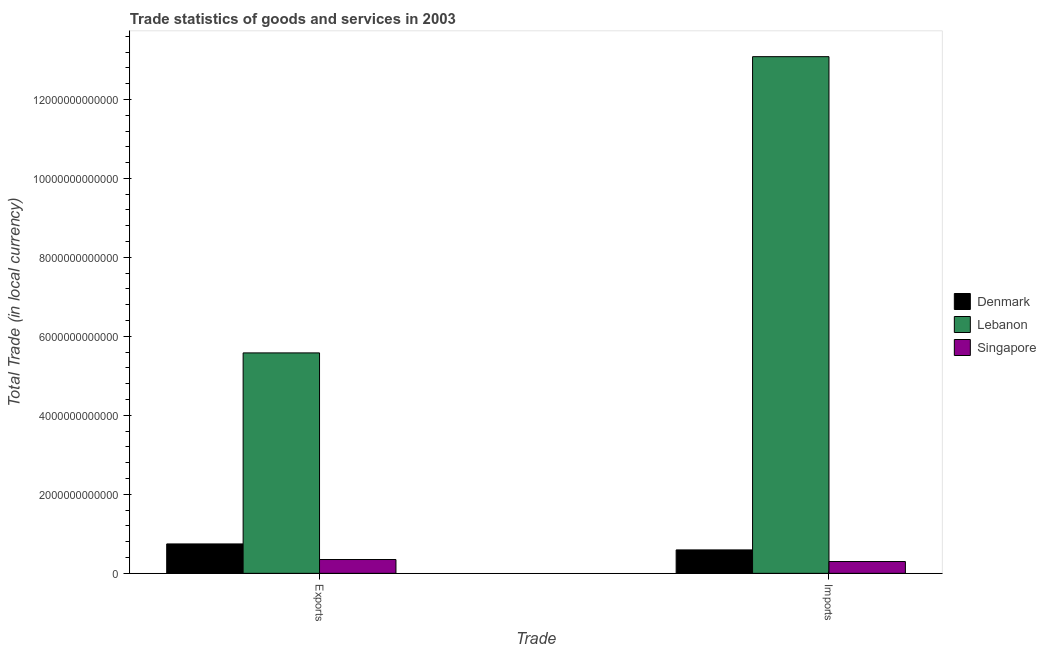How many different coloured bars are there?
Ensure brevity in your answer.  3. How many bars are there on the 2nd tick from the left?
Provide a short and direct response. 3. What is the label of the 1st group of bars from the left?
Offer a terse response. Exports. What is the imports of goods and services in Lebanon?
Provide a succinct answer. 1.31e+13. Across all countries, what is the maximum export of goods and services?
Offer a very short reply. 5.58e+12. Across all countries, what is the minimum imports of goods and services?
Offer a very short reply. 2.99e+11. In which country was the export of goods and services maximum?
Provide a short and direct response. Lebanon. In which country was the imports of goods and services minimum?
Offer a terse response. Singapore. What is the total export of goods and services in the graph?
Your response must be concise. 6.68e+12. What is the difference between the export of goods and services in Lebanon and that in Denmark?
Provide a succinct answer. 4.84e+12. What is the difference between the imports of goods and services in Singapore and the export of goods and services in Denmark?
Your answer should be very brief. -4.45e+11. What is the average export of goods and services per country?
Your answer should be very brief. 2.23e+12. What is the difference between the imports of goods and services and export of goods and services in Singapore?
Keep it short and to the point. -5.08e+1. What is the ratio of the imports of goods and services in Singapore to that in Lebanon?
Give a very brief answer. 0.02. Is the export of goods and services in Denmark less than that in Singapore?
Your response must be concise. No. In how many countries, is the imports of goods and services greater than the average imports of goods and services taken over all countries?
Ensure brevity in your answer.  1. What does the 1st bar from the left in Imports represents?
Your answer should be very brief. Denmark. How many countries are there in the graph?
Your response must be concise. 3. What is the difference between two consecutive major ticks on the Y-axis?
Your answer should be very brief. 2.00e+12. Are the values on the major ticks of Y-axis written in scientific E-notation?
Offer a terse response. No. Does the graph contain grids?
Offer a very short reply. No. How many legend labels are there?
Keep it short and to the point. 3. What is the title of the graph?
Ensure brevity in your answer.  Trade statistics of goods and services in 2003. What is the label or title of the X-axis?
Keep it short and to the point. Trade. What is the label or title of the Y-axis?
Your answer should be very brief. Total Trade (in local currency). What is the Total Trade (in local currency) of Denmark in Exports?
Keep it short and to the point. 7.44e+11. What is the Total Trade (in local currency) of Lebanon in Exports?
Make the answer very short. 5.58e+12. What is the Total Trade (in local currency) of Singapore in Exports?
Make the answer very short. 3.50e+11. What is the Total Trade (in local currency) in Denmark in Imports?
Give a very brief answer. 5.93e+11. What is the Total Trade (in local currency) in Lebanon in Imports?
Ensure brevity in your answer.  1.31e+13. What is the Total Trade (in local currency) in Singapore in Imports?
Give a very brief answer. 2.99e+11. Across all Trade, what is the maximum Total Trade (in local currency) in Denmark?
Your answer should be very brief. 7.44e+11. Across all Trade, what is the maximum Total Trade (in local currency) of Lebanon?
Ensure brevity in your answer.  1.31e+13. Across all Trade, what is the maximum Total Trade (in local currency) in Singapore?
Your answer should be very brief. 3.50e+11. Across all Trade, what is the minimum Total Trade (in local currency) in Denmark?
Make the answer very short. 5.93e+11. Across all Trade, what is the minimum Total Trade (in local currency) in Lebanon?
Give a very brief answer. 5.58e+12. Across all Trade, what is the minimum Total Trade (in local currency) in Singapore?
Keep it short and to the point. 2.99e+11. What is the total Total Trade (in local currency) in Denmark in the graph?
Give a very brief answer. 1.34e+12. What is the total Total Trade (in local currency) in Lebanon in the graph?
Your answer should be compact. 1.87e+13. What is the total Total Trade (in local currency) of Singapore in the graph?
Your response must be concise. 6.49e+11. What is the difference between the Total Trade (in local currency) of Denmark in Exports and that in Imports?
Provide a short and direct response. 1.51e+11. What is the difference between the Total Trade (in local currency) of Lebanon in Exports and that in Imports?
Provide a succinct answer. -7.50e+12. What is the difference between the Total Trade (in local currency) in Singapore in Exports and that in Imports?
Keep it short and to the point. 5.08e+1. What is the difference between the Total Trade (in local currency) of Denmark in Exports and the Total Trade (in local currency) of Lebanon in Imports?
Your response must be concise. -1.23e+13. What is the difference between the Total Trade (in local currency) in Denmark in Exports and the Total Trade (in local currency) in Singapore in Imports?
Offer a very short reply. 4.45e+11. What is the difference between the Total Trade (in local currency) of Lebanon in Exports and the Total Trade (in local currency) of Singapore in Imports?
Make the answer very short. 5.28e+12. What is the average Total Trade (in local currency) in Denmark per Trade?
Your answer should be very brief. 6.69e+11. What is the average Total Trade (in local currency) of Lebanon per Trade?
Offer a very short reply. 9.33e+12. What is the average Total Trade (in local currency) of Singapore per Trade?
Your answer should be very brief. 3.24e+11. What is the difference between the Total Trade (in local currency) in Denmark and Total Trade (in local currency) in Lebanon in Exports?
Your answer should be very brief. -4.84e+12. What is the difference between the Total Trade (in local currency) of Denmark and Total Trade (in local currency) of Singapore in Exports?
Your answer should be very brief. 3.95e+11. What is the difference between the Total Trade (in local currency) of Lebanon and Total Trade (in local currency) of Singapore in Exports?
Make the answer very short. 5.23e+12. What is the difference between the Total Trade (in local currency) of Denmark and Total Trade (in local currency) of Lebanon in Imports?
Your response must be concise. -1.25e+13. What is the difference between the Total Trade (in local currency) in Denmark and Total Trade (in local currency) in Singapore in Imports?
Keep it short and to the point. 2.94e+11. What is the difference between the Total Trade (in local currency) in Lebanon and Total Trade (in local currency) in Singapore in Imports?
Your answer should be compact. 1.28e+13. What is the ratio of the Total Trade (in local currency) in Denmark in Exports to that in Imports?
Ensure brevity in your answer.  1.26. What is the ratio of the Total Trade (in local currency) of Lebanon in Exports to that in Imports?
Your response must be concise. 0.43. What is the ratio of the Total Trade (in local currency) of Singapore in Exports to that in Imports?
Provide a short and direct response. 1.17. What is the difference between the highest and the second highest Total Trade (in local currency) in Denmark?
Provide a short and direct response. 1.51e+11. What is the difference between the highest and the second highest Total Trade (in local currency) in Lebanon?
Give a very brief answer. 7.50e+12. What is the difference between the highest and the second highest Total Trade (in local currency) in Singapore?
Ensure brevity in your answer.  5.08e+1. What is the difference between the highest and the lowest Total Trade (in local currency) in Denmark?
Ensure brevity in your answer.  1.51e+11. What is the difference between the highest and the lowest Total Trade (in local currency) in Lebanon?
Your response must be concise. 7.50e+12. What is the difference between the highest and the lowest Total Trade (in local currency) in Singapore?
Offer a terse response. 5.08e+1. 